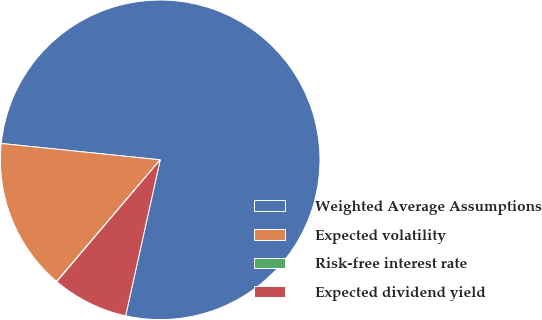Convert chart. <chart><loc_0><loc_0><loc_500><loc_500><pie_chart><fcel>Weighted Average Assumptions<fcel>Expected volatility<fcel>Risk-free interest rate<fcel>Expected dividend yield<nl><fcel>76.83%<fcel>15.4%<fcel>0.04%<fcel>7.72%<nl></chart> 